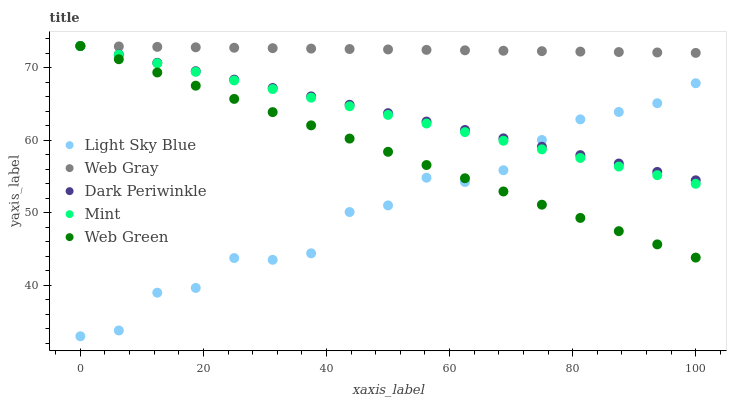Does Light Sky Blue have the minimum area under the curve?
Answer yes or no. Yes. Does Web Gray have the maximum area under the curve?
Answer yes or no. Yes. Does Web Gray have the minimum area under the curve?
Answer yes or no. No. Does Light Sky Blue have the maximum area under the curve?
Answer yes or no. No. Is Mint the smoothest?
Answer yes or no. Yes. Is Light Sky Blue the roughest?
Answer yes or no. Yes. Is Web Gray the smoothest?
Answer yes or no. No. Is Web Gray the roughest?
Answer yes or no. No. Does Light Sky Blue have the lowest value?
Answer yes or no. Yes. Does Web Gray have the lowest value?
Answer yes or no. No. Does Web Green have the highest value?
Answer yes or no. Yes. Does Light Sky Blue have the highest value?
Answer yes or no. No. Is Light Sky Blue less than Web Gray?
Answer yes or no. Yes. Is Web Gray greater than Light Sky Blue?
Answer yes or no. Yes. Does Web Gray intersect Mint?
Answer yes or no. Yes. Is Web Gray less than Mint?
Answer yes or no. No. Is Web Gray greater than Mint?
Answer yes or no. No. Does Light Sky Blue intersect Web Gray?
Answer yes or no. No. 